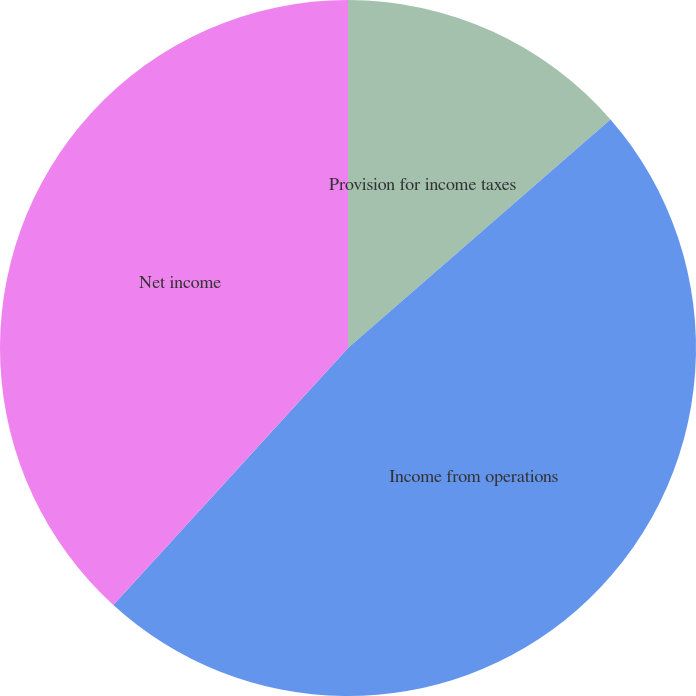Convert chart to OTSL. <chart><loc_0><loc_0><loc_500><loc_500><pie_chart><fcel>Provision for income taxes<fcel>Income from operations<fcel>Net income<fcel>Diluted earnings per share<nl><fcel>13.6%<fcel>48.18%<fcel>38.22%<fcel>0.0%<nl></chart> 